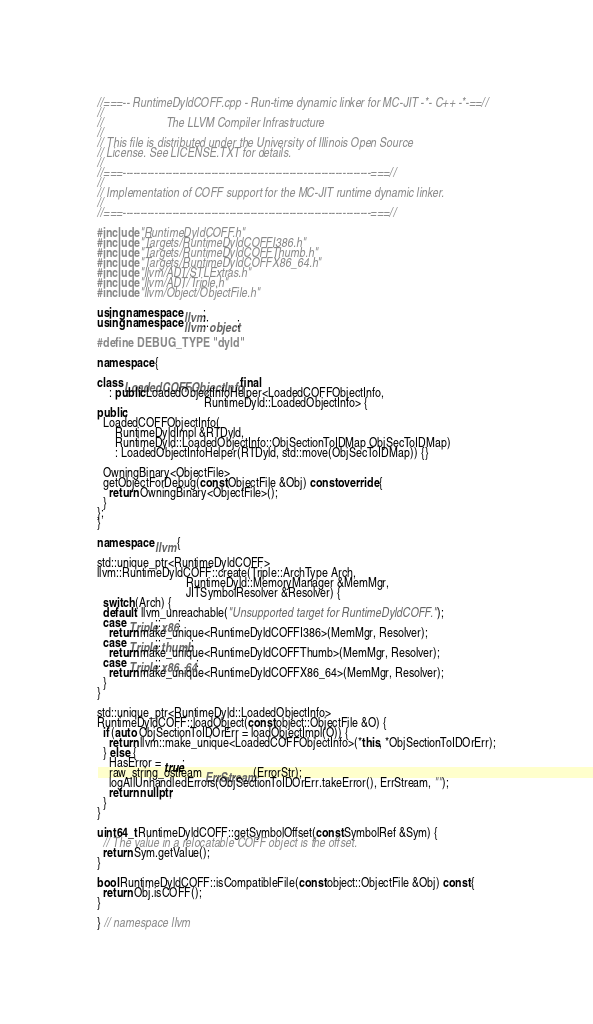<code> <loc_0><loc_0><loc_500><loc_500><_C++_>//===-- RuntimeDyldCOFF.cpp - Run-time dynamic linker for MC-JIT -*- C++ -*-==//
//
//                     The LLVM Compiler Infrastructure
//
// This file is distributed under the University of Illinois Open Source
// License. See LICENSE.TXT for details.
//
//===----------------------------------------------------------------------===//
//
// Implementation of COFF support for the MC-JIT runtime dynamic linker.
//
//===----------------------------------------------------------------------===//

#include "RuntimeDyldCOFF.h"
#include "Targets/RuntimeDyldCOFFI386.h"
#include "Targets/RuntimeDyldCOFFThumb.h"
#include "Targets/RuntimeDyldCOFFX86_64.h"
#include "llvm/ADT/STLExtras.h"
#include "llvm/ADT/Triple.h"
#include "llvm/Object/ObjectFile.h"

using namespace llvm;
using namespace llvm::object;

#define DEBUG_TYPE "dyld"

namespace {

class LoadedCOFFObjectInfo final
    : public LoadedObjectInfoHelper<LoadedCOFFObjectInfo,
                                    RuntimeDyld::LoadedObjectInfo> {
public:
  LoadedCOFFObjectInfo(
      RuntimeDyldImpl &RTDyld,
      RuntimeDyld::LoadedObjectInfo::ObjSectionToIDMap ObjSecToIDMap)
      : LoadedObjectInfoHelper(RTDyld, std::move(ObjSecToIDMap)) {}

  OwningBinary<ObjectFile>
  getObjectForDebug(const ObjectFile &Obj) const override {
    return OwningBinary<ObjectFile>();
  }
};
}

namespace llvm {

std::unique_ptr<RuntimeDyldCOFF>
llvm::RuntimeDyldCOFF::create(Triple::ArchType Arch,
                              RuntimeDyld::MemoryManager &MemMgr,
                              JITSymbolResolver &Resolver) {
  switch (Arch) {
  default: llvm_unreachable("Unsupported target for RuntimeDyldCOFF.");
  case Triple::x86:
    return make_unique<RuntimeDyldCOFFI386>(MemMgr, Resolver);
  case Triple::thumb:
    return make_unique<RuntimeDyldCOFFThumb>(MemMgr, Resolver);
  case Triple::x86_64:
    return make_unique<RuntimeDyldCOFFX86_64>(MemMgr, Resolver);
  }
}

std::unique_ptr<RuntimeDyld::LoadedObjectInfo>
RuntimeDyldCOFF::loadObject(const object::ObjectFile &O) {
  if (auto ObjSectionToIDOrErr = loadObjectImpl(O)) {
    return llvm::make_unique<LoadedCOFFObjectInfo>(*this, *ObjSectionToIDOrErr);
  } else {
    HasError = true;
    raw_string_ostream ErrStream(ErrorStr);
    logAllUnhandledErrors(ObjSectionToIDOrErr.takeError(), ErrStream, "");
    return nullptr;
  }
}

uint64_t RuntimeDyldCOFF::getSymbolOffset(const SymbolRef &Sym) {
  // The value in a relocatable COFF object is the offset.
  return Sym.getValue();
}

bool RuntimeDyldCOFF::isCompatibleFile(const object::ObjectFile &Obj) const {
  return Obj.isCOFF();
}

} // namespace llvm
</code> 